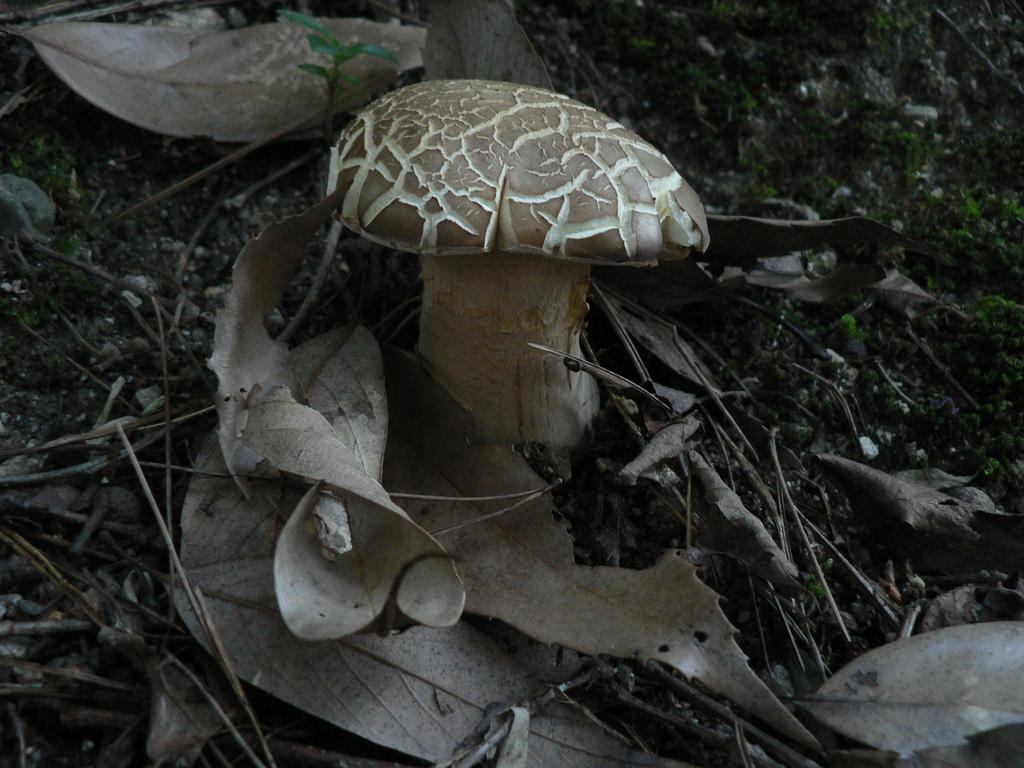What is the main subject in the center of the image? There is a mushroom in the center of the image. What type of vegetation is present at the bottom of the image? There are leaves at the bottom of the image. What other natural elements can be seen in the image? There are twigs visible in the image. What type of locket is hanging from the mushroom in the image? There is no locket present in the image; it features a mushroom, leaves, and twigs. 